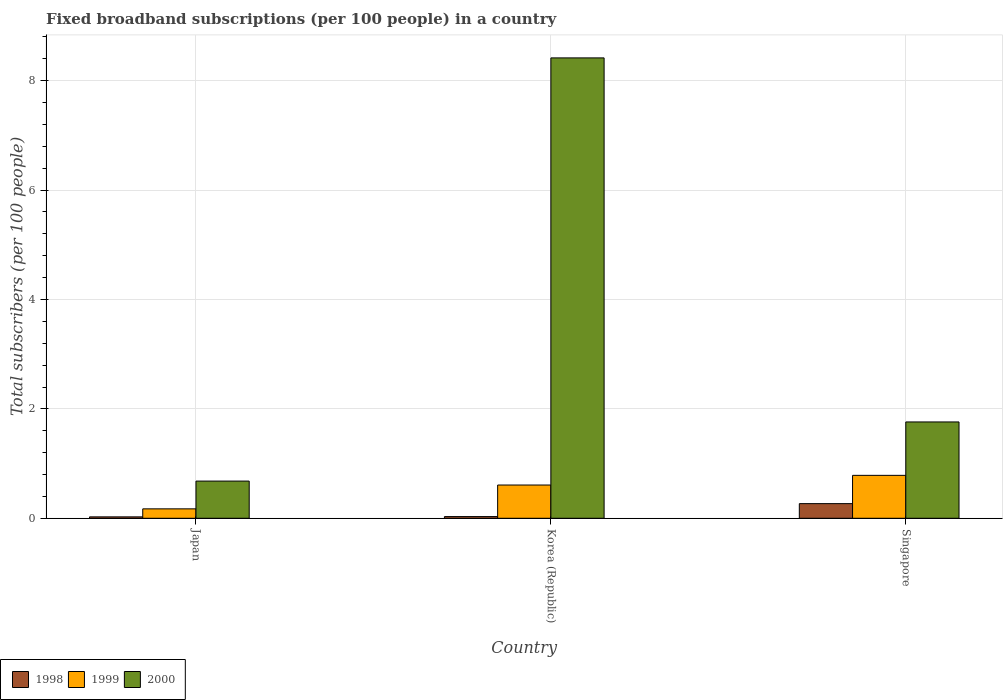How many different coloured bars are there?
Ensure brevity in your answer.  3. Are the number of bars per tick equal to the number of legend labels?
Ensure brevity in your answer.  Yes. Are the number of bars on each tick of the X-axis equal?
Your answer should be compact. Yes. How many bars are there on the 1st tick from the right?
Offer a terse response. 3. What is the label of the 2nd group of bars from the left?
Your answer should be very brief. Korea (Republic). In how many cases, is the number of bars for a given country not equal to the number of legend labels?
Make the answer very short. 0. What is the number of broadband subscriptions in 2000 in Korea (Republic)?
Your response must be concise. 8.42. Across all countries, what is the maximum number of broadband subscriptions in 1999?
Provide a succinct answer. 0.78. Across all countries, what is the minimum number of broadband subscriptions in 2000?
Make the answer very short. 0.68. In which country was the number of broadband subscriptions in 1999 maximum?
Your response must be concise. Singapore. In which country was the number of broadband subscriptions in 2000 minimum?
Provide a short and direct response. Japan. What is the total number of broadband subscriptions in 1998 in the graph?
Ensure brevity in your answer.  0.32. What is the difference between the number of broadband subscriptions in 1998 in Japan and that in Korea (Republic)?
Ensure brevity in your answer.  -0.01. What is the difference between the number of broadband subscriptions in 1998 in Japan and the number of broadband subscriptions in 2000 in Korea (Republic)?
Give a very brief answer. -8.39. What is the average number of broadband subscriptions in 1998 per country?
Your answer should be compact. 0.11. What is the difference between the number of broadband subscriptions of/in 1998 and number of broadband subscriptions of/in 2000 in Singapore?
Offer a terse response. -1.49. What is the ratio of the number of broadband subscriptions in 1999 in Korea (Republic) to that in Singapore?
Your response must be concise. 0.77. What is the difference between the highest and the second highest number of broadband subscriptions in 1999?
Provide a short and direct response. 0.18. What is the difference between the highest and the lowest number of broadband subscriptions in 1999?
Make the answer very short. 0.61. In how many countries, is the number of broadband subscriptions in 1999 greater than the average number of broadband subscriptions in 1999 taken over all countries?
Provide a short and direct response. 2. What does the 3rd bar from the left in Singapore represents?
Provide a short and direct response. 2000. What does the 2nd bar from the right in Korea (Republic) represents?
Give a very brief answer. 1999. How many bars are there?
Give a very brief answer. 9. What is the difference between two consecutive major ticks on the Y-axis?
Your answer should be very brief. 2. Are the values on the major ticks of Y-axis written in scientific E-notation?
Ensure brevity in your answer.  No. Does the graph contain grids?
Keep it short and to the point. Yes. How many legend labels are there?
Your response must be concise. 3. What is the title of the graph?
Offer a very short reply. Fixed broadband subscriptions (per 100 people) in a country. What is the label or title of the Y-axis?
Provide a short and direct response. Total subscribers (per 100 people). What is the Total subscribers (per 100 people) in 1998 in Japan?
Make the answer very short. 0.03. What is the Total subscribers (per 100 people) of 1999 in Japan?
Provide a short and direct response. 0.17. What is the Total subscribers (per 100 people) of 2000 in Japan?
Make the answer very short. 0.68. What is the Total subscribers (per 100 people) in 1998 in Korea (Republic)?
Your response must be concise. 0.03. What is the Total subscribers (per 100 people) in 1999 in Korea (Republic)?
Provide a succinct answer. 0.61. What is the Total subscribers (per 100 people) of 2000 in Korea (Republic)?
Your answer should be compact. 8.42. What is the Total subscribers (per 100 people) of 1998 in Singapore?
Ensure brevity in your answer.  0.27. What is the Total subscribers (per 100 people) in 1999 in Singapore?
Your answer should be very brief. 0.78. What is the Total subscribers (per 100 people) of 2000 in Singapore?
Your answer should be compact. 1.76. Across all countries, what is the maximum Total subscribers (per 100 people) in 1998?
Offer a terse response. 0.27. Across all countries, what is the maximum Total subscribers (per 100 people) of 1999?
Your answer should be very brief. 0.78. Across all countries, what is the maximum Total subscribers (per 100 people) in 2000?
Provide a short and direct response. 8.42. Across all countries, what is the minimum Total subscribers (per 100 people) of 1998?
Provide a short and direct response. 0.03. Across all countries, what is the minimum Total subscribers (per 100 people) in 1999?
Your answer should be very brief. 0.17. Across all countries, what is the minimum Total subscribers (per 100 people) in 2000?
Ensure brevity in your answer.  0.68. What is the total Total subscribers (per 100 people) of 1998 in the graph?
Offer a very short reply. 0.32. What is the total Total subscribers (per 100 people) of 1999 in the graph?
Your response must be concise. 1.56. What is the total Total subscribers (per 100 people) in 2000 in the graph?
Ensure brevity in your answer.  10.86. What is the difference between the Total subscribers (per 100 people) of 1998 in Japan and that in Korea (Republic)?
Give a very brief answer. -0.01. What is the difference between the Total subscribers (per 100 people) of 1999 in Japan and that in Korea (Republic)?
Keep it short and to the point. -0.44. What is the difference between the Total subscribers (per 100 people) in 2000 in Japan and that in Korea (Republic)?
Make the answer very short. -7.74. What is the difference between the Total subscribers (per 100 people) in 1998 in Japan and that in Singapore?
Your answer should be compact. -0.24. What is the difference between the Total subscribers (per 100 people) in 1999 in Japan and that in Singapore?
Keep it short and to the point. -0.61. What is the difference between the Total subscribers (per 100 people) of 2000 in Japan and that in Singapore?
Offer a terse response. -1.08. What is the difference between the Total subscribers (per 100 people) of 1998 in Korea (Republic) and that in Singapore?
Your response must be concise. -0.24. What is the difference between the Total subscribers (per 100 people) of 1999 in Korea (Republic) and that in Singapore?
Your answer should be very brief. -0.18. What is the difference between the Total subscribers (per 100 people) in 2000 in Korea (Republic) and that in Singapore?
Make the answer very short. 6.66. What is the difference between the Total subscribers (per 100 people) in 1998 in Japan and the Total subscribers (per 100 people) in 1999 in Korea (Republic)?
Give a very brief answer. -0.58. What is the difference between the Total subscribers (per 100 people) in 1998 in Japan and the Total subscribers (per 100 people) in 2000 in Korea (Republic)?
Give a very brief answer. -8.39. What is the difference between the Total subscribers (per 100 people) of 1999 in Japan and the Total subscribers (per 100 people) of 2000 in Korea (Republic)?
Offer a very short reply. -8.25. What is the difference between the Total subscribers (per 100 people) in 1998 in Japan and the Total subscribers (per 100 people) in 1999 in Singapore?
Ensure brevity in your answer.  -0.76. What is the difference between the Total subscribers (per 100 people) in 1998 in Japan and the Total subscribers (per 100 people) in 2000 in Singapore?
Provide a short and direct response. -1.74. What is the difference between the Total subscribers (per 100 people) of 1999 in Japan and the Total subscribers (per 100 people) of 2000 in Singapore?
Keep it short and to the point. -1.59. What is the difference between the Total subscribers (per 100 people) of 1998 in Korea (Republic) and the Total subscribers (per 100 people) of 1999 in Singapore?
Provide a short and direct response. -0.75. What is the difference between the Total subscribers (per 100 people) in 1998 in Korea (Republic) and the Total subscribers (per 100 people) in 2000 in Singapore?
Offer a terse response. -1.73. What is the difference between the Total subscribers (per 100 people) in 1999 in Korea (Republic) and the Total subscribers (per 100 people) in 2000 in Singapore?
Your answer should be very brief. -1.15. What is the average Total subscribers (per 100 people) of 1998 per country?
Offer a very short reply. 0.11. What is the average Total subscribers (per 100 people) in 1999 per country?
Provide a succinct answer. 0.52. What is the average Total subscribers (per 100 people) of 2000 per country?
Provide a succinct answer. 3.62. What is the difference between the Total subscribers (per 100 people) in 1998 and Total subscribers (per 100 people) in 1999 in Japan?
Keep it short and to the point. -0.15. What is the difference between the Total subscribers (per 100 people) of 1998 and Total subscribers (per 100 people) of 2000 in Japan?
Give a very brief answer. -0.65. What is the difference between the Total subscribers (per 100 people) of 1999 and Total subscribers (per 100 people) of 2000 in Japan?
Your answer should be compact. -0.51. What is the difference between the Total subscribers (per 100 people) of 1998 and Total subscribers (per 100 people) of 1999 in Korea (Republic)?
Ensure brevity in your answer.  -0.58. What is the difference between the Total subscribers (per 100 people) of 1998 and Total subscribers (per 100 people) of 2000 in Korea (Republic)?
Your response must be concise. -8.39. What is the difference between the Total subscribers (per 100 people) of 1999 and Total subscribers (per 100 people) of 2000 in Korea (Republic)?
Provide a succinct answer. -7.81. What is the difference between the Total subscribers (per 100 people) in 1998 and Total subscribers (per 100 people) in 1999 in Singapore?
Your answer should be very brief. -0.52. What is the difference between the Total subscribers (per 100 people) in 1998 and Total subscribers (per 100 people) in 2000 in Singapore?
Your answer should be very brief. -1.49. What is the difference between the Total subscribers (per 100 people) of 1999 and Total subscribers (per 100 people) of 2000 in Singapore?
Offer a very short reply. -0.98. What is the ratio of the Total subscribers (per 100 people) in 1998 in Japan to that in Korea (Republic)?
Your answer should be compact. 0.83. What is the ratio of the Total subscribers (per 100 people) in 1999 in Japan to that in Korea (Republic)?
Provide a succinct answer. 0.28. What is the ratio of the Total subscribers (per 100 people) of 2000 in Japan to that in Korea (Republic)?
Offer a terse response. 0.08. What is the ratio of the Total subscribers (per 100 people) in 1998 in Japan to that in Singapore?
Your response must be concise. 0.1. What is the ratio of the Total subscribers (per 100 people) of 1999 in Japan to that in Singapore?
Offer a very short reply. 0.22. What is the ratio of the Total subscribers (per 100 people) of 2000 in Japan to that in Singapore?
Keep it short and to the point. 0.39. What is the ratio of the Total subscribers (per 100 people) of 1998 in Korea (Republic) to that in Singapore?
Provide a short and direct response. 0.12. What is the ratio of the Total subscribers (per 100 people) in 1999 in Korea (Republic) to that in Singapore?
Ensure brevity in your answer.  0.77. What is the ratio of the Total subscribers (per 100 people) of 2000 in Korea (Republic) to that in Singapore?
Give a very brief answer. 4.78. What is the difference between the highest and the second highest Total subscribers (per 100 people) of 1998?
Keep it short and to the point. 0.24. What is the difference between the highest and the second highest Total subscribers (per 100 people) of 1999?
Provide a succinct answer. 0.18. What is the difference between the highest and the second highest Total subscribers (per 100 people) of 2000?
Ensure brevity in your answer.  6.66. What is the difference between the highest and the lowest Total subscribers (per 100 people) in 1998?
Give a very brief answer. 0.24. What is the difference between the highest and the lowest Total subscribers (per 100 people) in 1999?
Your answer should be compact. 0.61. What is the difference between the highest and the lowest Total subscribers (per 100 people) of 2000?
Make the answer very short. 7.74. 